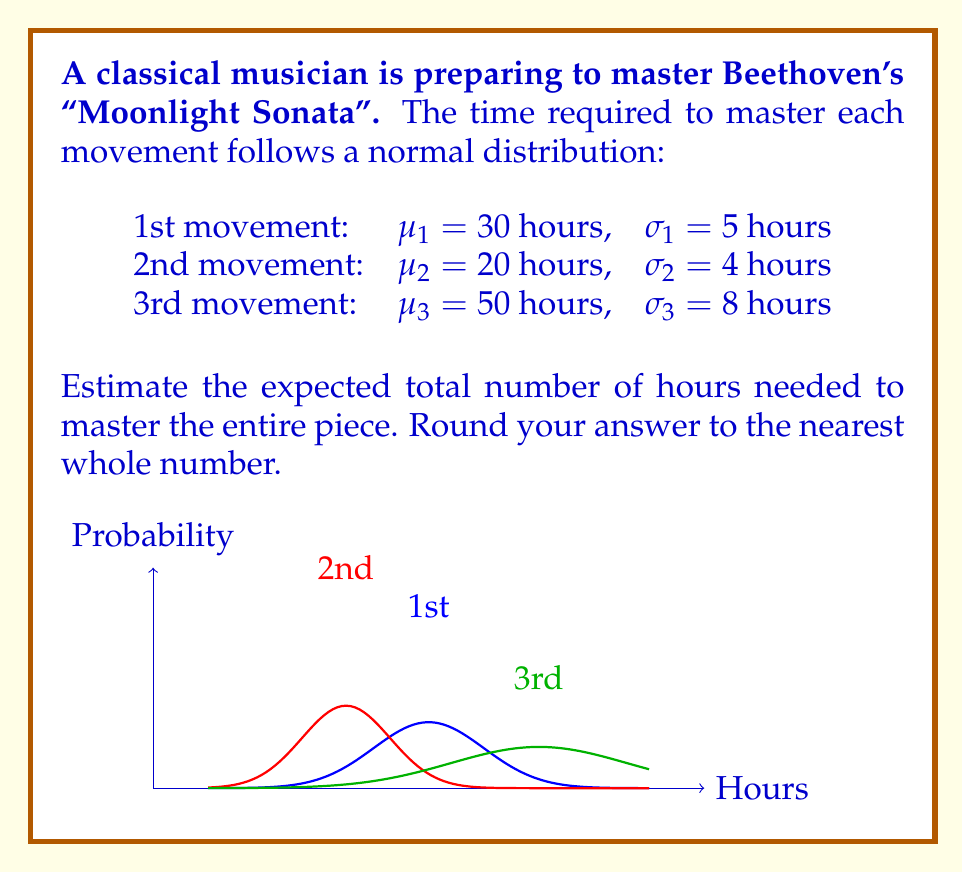Show me your answer to this math problem. To estimate the expected total number of hours, we need to sum the expected values (means) of each movement:

1. The expected value for a normal distribution is its mean ($\mu$).

2. For the 1st movement: $E(X_1) = \mu_1 = 30$ hours

3. For the 2nd movement: $E(X_2) = \mu_2 = 20$ hours

4. For the 3rd movement: $E(X_3) = \mu_3 = 50$ hours

5. The expected total time is the sum of these individual expectations:

   $E(X_{total}) = E(X_1) + E(X_2) + E(X_3)$

6. Substituting the values:

   $E(X_{total}) = 30 + 20 + 50 = 100$ hours

7. The question asks to round to the nearest whole number, but 100 is already a whole number.

Therefore, the expected total number of hours needed to master the entire "Moonlight Sonata" is 100 hours.
Answer: 100 hours 